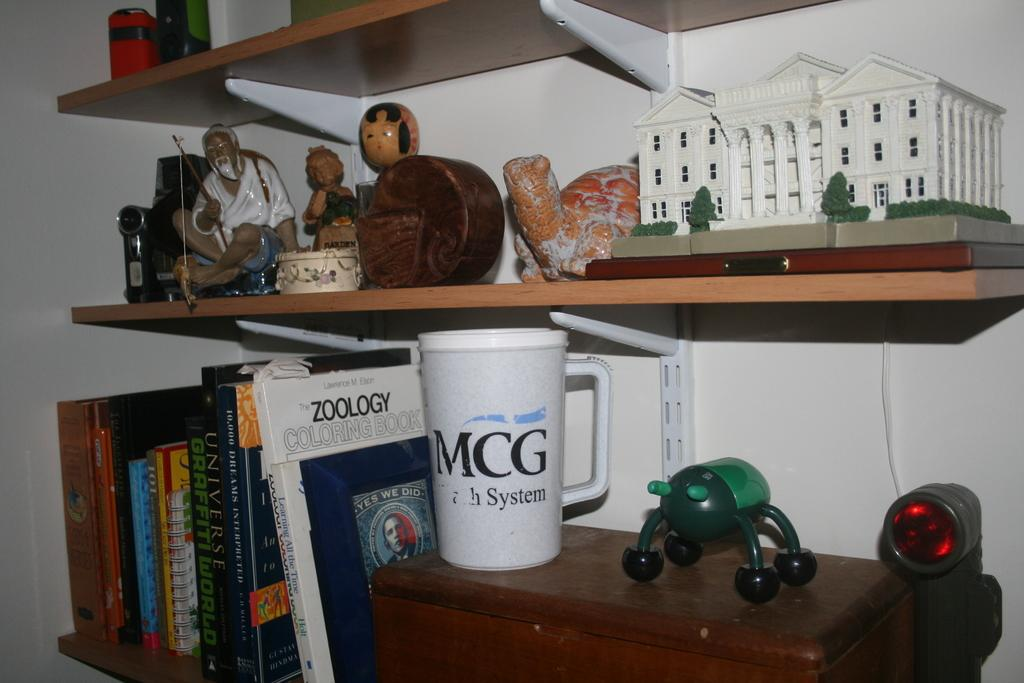What type of items can be seen on the rack in the image? There are books, a mug, and a toy building on the rack in the image. What is the purpose of the mug in the image? The purpose of the mug in the image is likely for holding a beverage. What is the toy building made of? The toy building in the image is made of plastic or another material suitable for toys. What can be seen in the background of the image? There is a wall visible in the background of the image. How many trees are visible in the image? There are no trees visible in the image; it features objects on a rack with a wall in the background. What type of division is taking place in the image? There is no division taking place in the image; it simply shows objects on a rack and a wall in the background. 